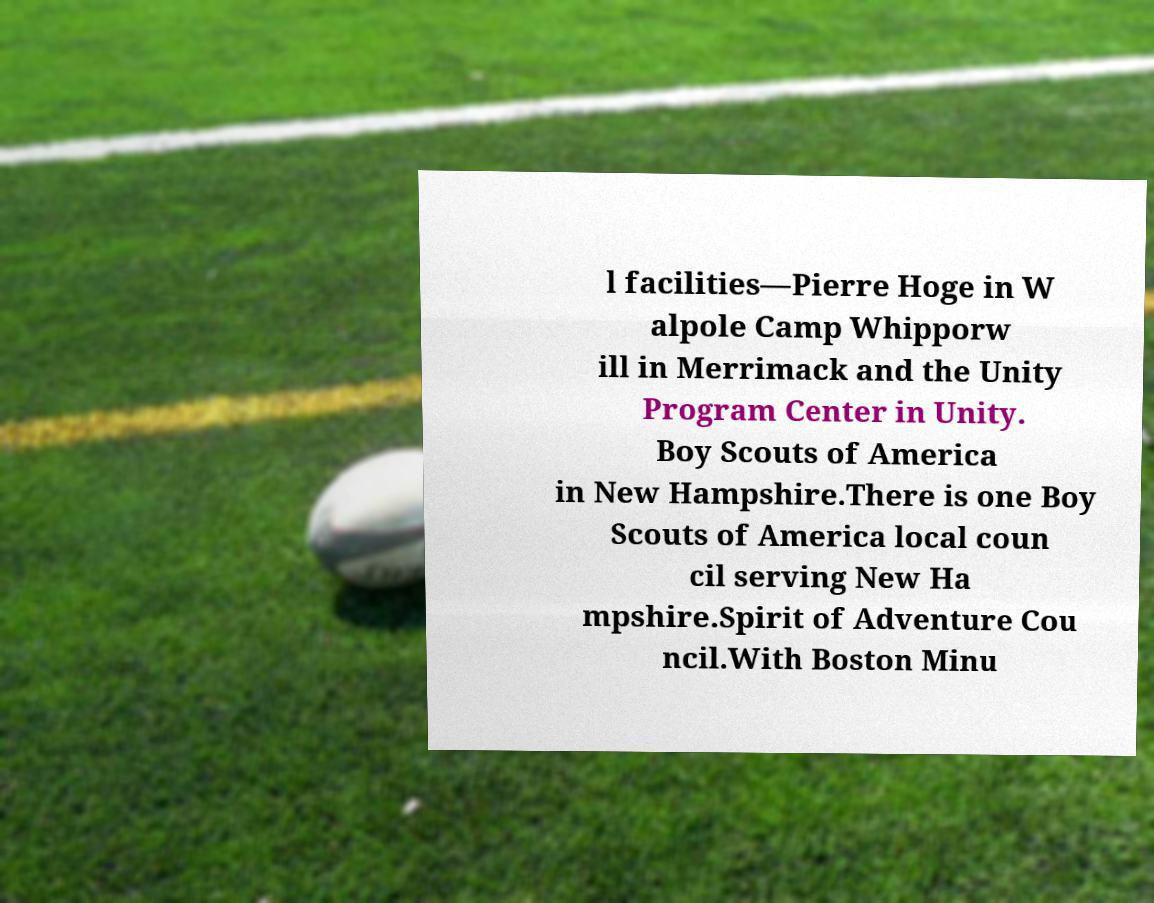I need the written content from this picture converted into text. Can you do that? l facilities—Pierre Hoge in W alpole Camp Whipporw ill in Merrimack and the Unity Program Center in Unity. Boy Scouts of America in New Hampshire.There is one Boy Scouts of America local coun cil serving New Ha mpshire.Spirit of Adventure Cou ncil.With Boston Minu 